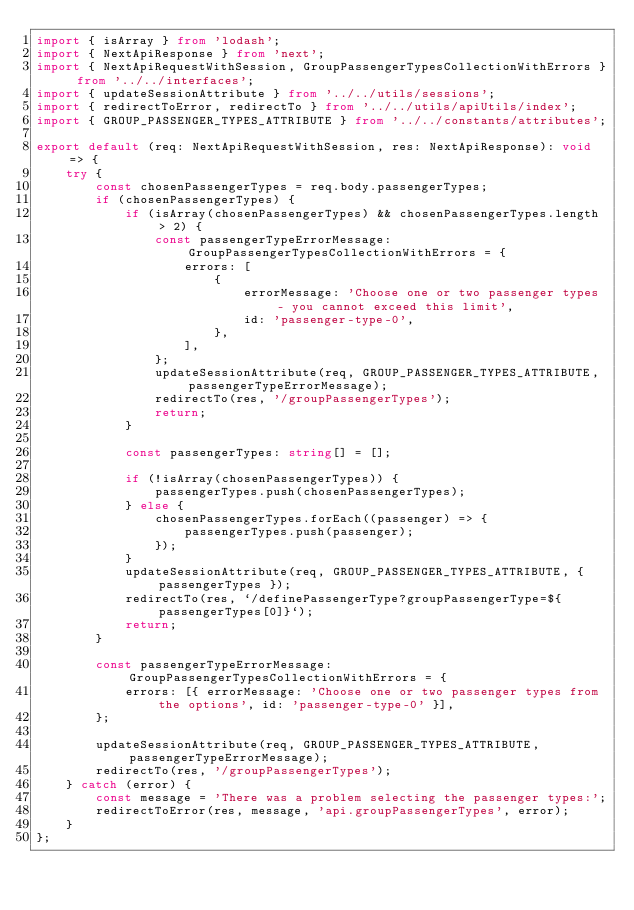Convert code to text. <code><loc_0><loc_0><loc_500><loc_500><_TypeScript_>import { isArray } from 'lodash';
import { NextApiResponse } from 'next';
import { NextApiRequestWithSession, GroupPassengerTypesCollectionWithErrors } from '../../interfaces';
import { updateSessionAttribute } from '../../utils/sessions';
import { redirectToError, redirectTo } from '../../utils/apiUtils/index';
import { GROUP_PASSENGER_TYPES_ATTRIBUTE } from '../../constants/attributes';

export default (req: NextApiRequestWithSession, res: NextApiResponse): void => {
    try {
        const chosenPassengerTypes = req.body.passengerTypes;
        if (chosenPassengerTypes) {
            if (isArray(chosenPassengerTypes) && chosenPassengerTypes.length > 2) {
                const passengerTypeErrorMessage: GroupPassengerTypesCollectionWithErrors = {
                    errors: [
                        {
                            errorMessage: 'Choose one or two passenger types - you cannot exceed this limit',
                            id: 'passenger-type-0',
                        },
                    ],
                };
                updateSessionAttribute(req, GROUP_PASSENGER_TYPES_ATTRIBUTE, passengerTypeErrorMessage);
                redirectTo(res, '/groupPassengerTypes');
                return;
            }

            const passengerTypes: string[] = [];

            if (!isArray(chosenPassengerTypes)) {
                passengerTypes.push(chosenPassengerTypes);
            } else {
                chosenPassengerTypes.forEach((passenger) => {
                    passengerTypes.push(passenger);
                });
            }
            updateSessionAttribute(req, GROUP_PASSENGER_TYPES_ATTRIBUTE, { passengerTypes });
            redirectTo(res, `/definePassengerType?groupPassengerType=${passengerTypes[0]}`);
            return;
        }

        const passengerTypeErrorMessage: GroupPassengerTypesCollectionWithErrors = {
            errors: [{ errorMessage: 'Choose one or two passenger types from the options', id: 'passenger-type-0' }],
        };

        updateSessionAttribute(req, GROUP_PASSENGER_TYPES_ATTRIBUTE, passengerTypeErrorMessage);
        redirectTo(res, '/groupPassengerTypes');
    } catch (error) {
        const message = 'There was a problem selecting the passenger types:';
        redirectToError(res, message, 'api.groupPassengerTypes', error);
    }
};
</code> 